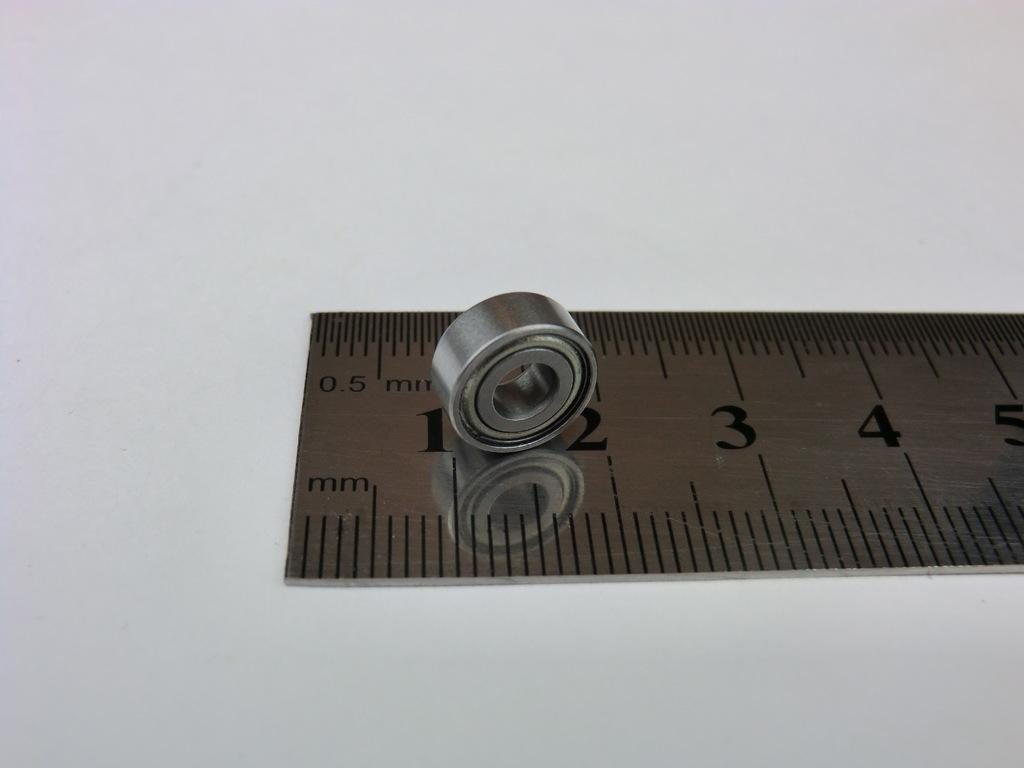<image>
Provide a brief description of the given image. A metal object sits on a metal ruler between the 1 and 2 centimeter marks. 